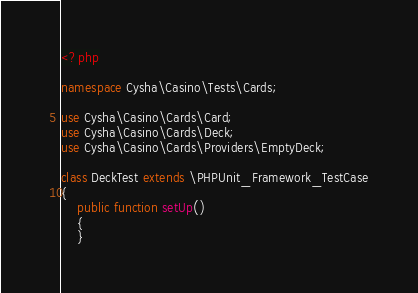Convert code to text. <code><loc_0><loc_0><loc_500><loc_500><_PHP_><?php

namespace Cysha\Casino\Tests\Cards;

use Cysha\Casino\Cards\Card;
use Cysha\Casino\Cards\Deck;
use Cysha\Casino\Cards\Providers\EmptyDeck;

class DeckTest extends \PHPUnit_Framework_TestCase
{
    public function setUp()
    {
    }
</code> 